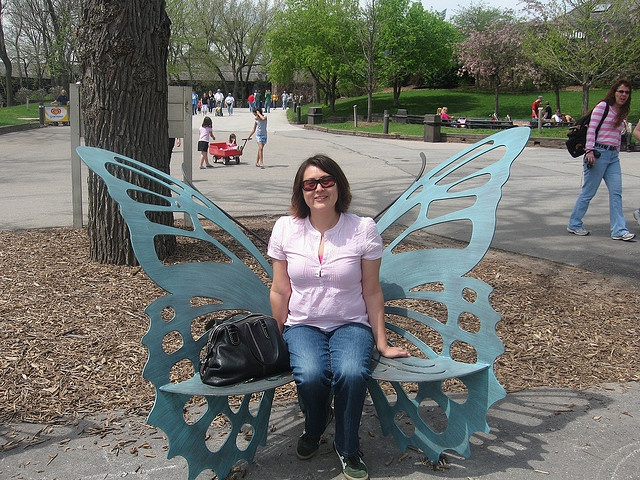Describe the objects in this image and their specific colors. I can see bench in maroon, gray, darkgray, and black tones, people in maroon, black, lavender, darkgray, and gray tones, people in maroon, gray, black, and darkgray tones, handbag in maroon, black, gray, and darkgray tones, and people in maroon, black, gray, lightgray, and darkgray tones in this image. 